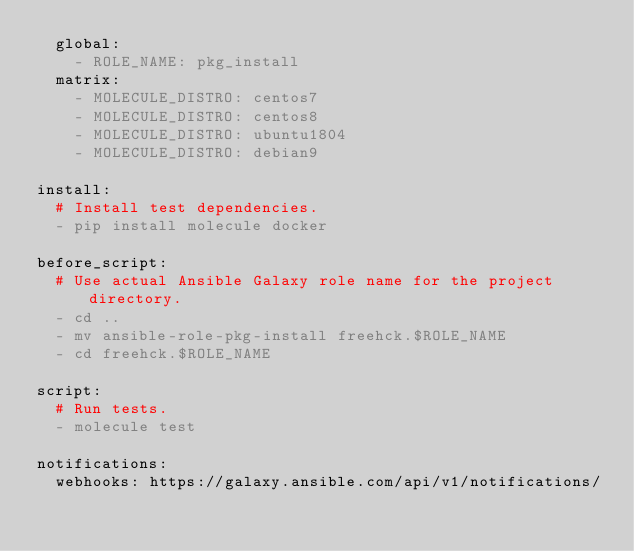Convert code to text. <code><loc_0><loc_0><loc_500><loc_500><_YAML_>  global:
    - ROLE_NAME: pkg_install
  matrix:
    - MOLECULE_DISTRO: centos7
    - MOLECULE_DISTRO: centos8
    - MOLECULE_DISTRO: ubuntu1804
    - MOLECULE_DISTRO: debian9

install:
  # Install test dependencies.
  - pip install molecule docker

before_script:
  # Use actual Ansible Galaxy role name for the project directory.
  - cd ..
  - mv ansible-role-pkg-install freehck.$ROLE_NAME
  - cd freehck.$ROLE_NAME

script:
  # Run tests.
  - molecule test

notifications:
  webhooks: https://galaxy.ansible.com/api/v1/notifications/
</code> 